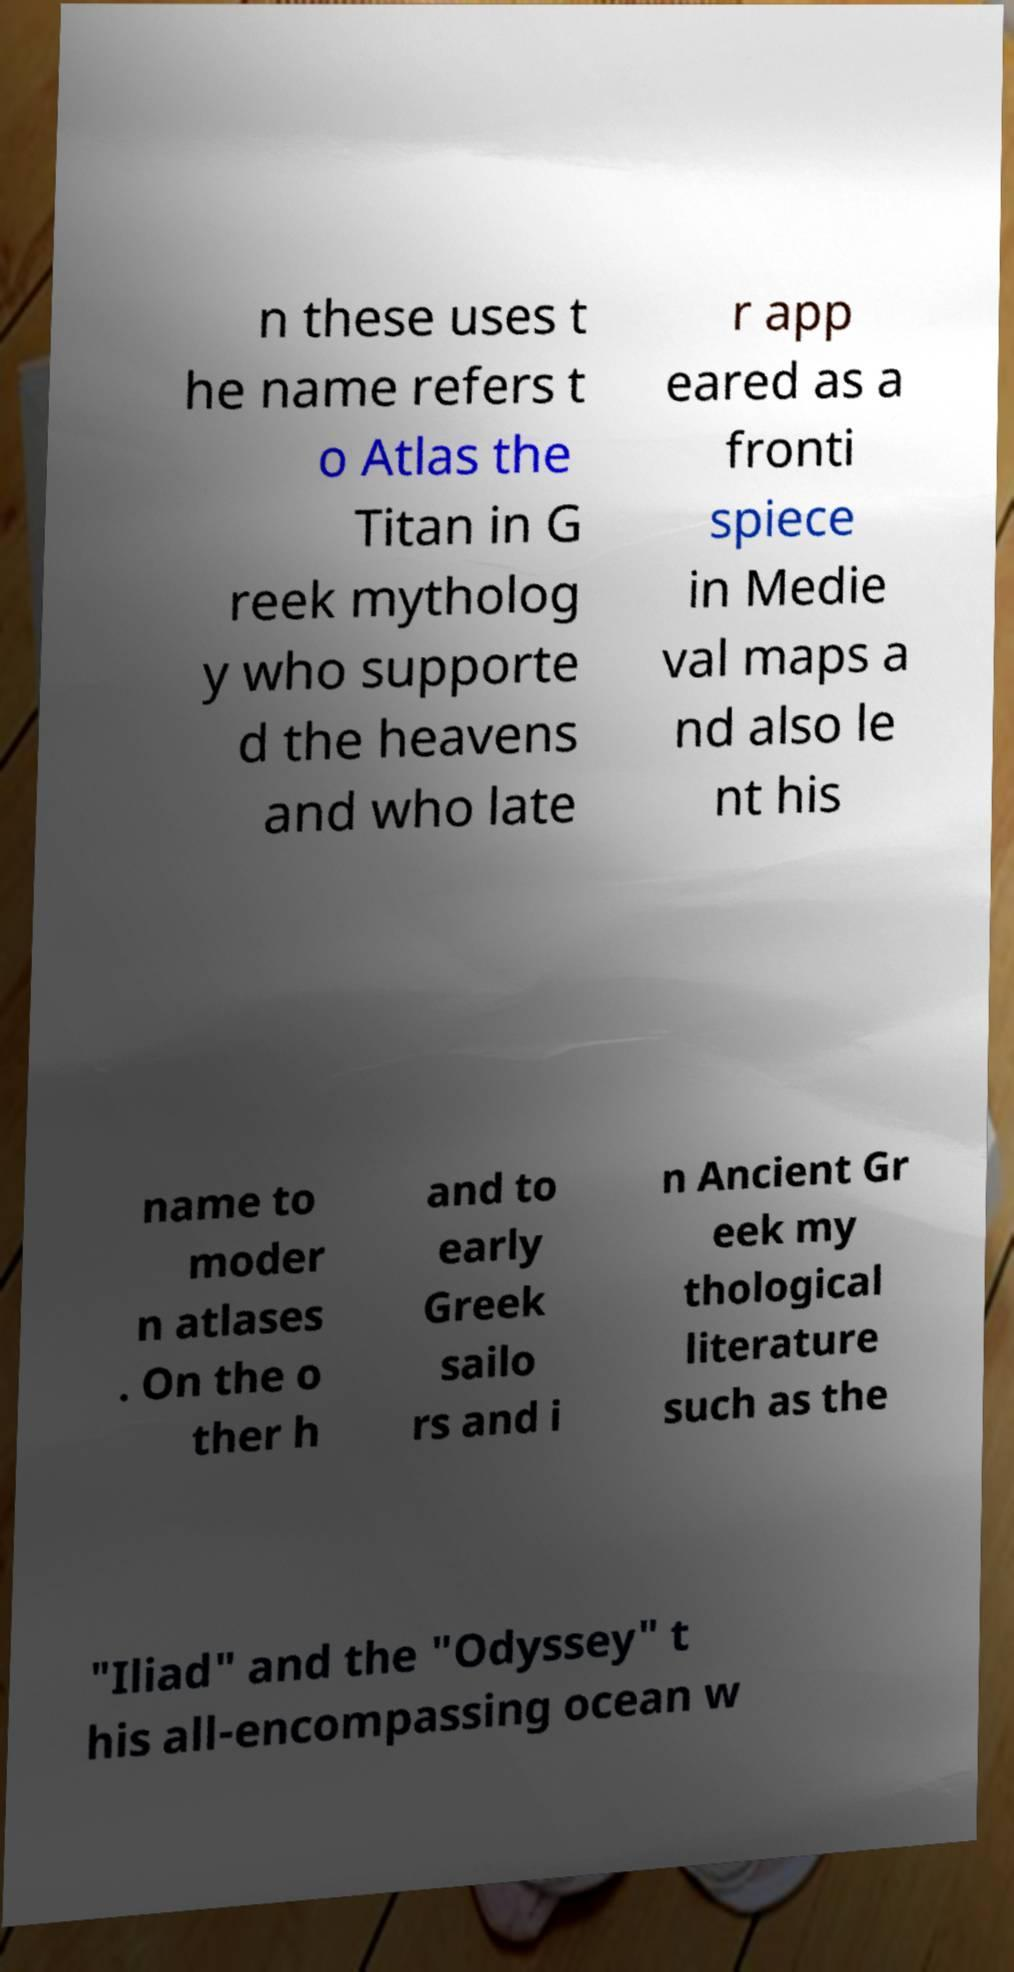Could you extract and type out the text from this image? n these uses t he name refers t o Atlas the Titan in G reek mytholog y who supporte d the heavens and who late r app eared as a fronti spiece in Medie val maps a nd also le nt his name to moder n atlases . On the o ther h and to early Greek sailo rs and i n Ancient Gr eek my thological literature such as the "Iliad" and the "Odyssey" t his all-encompassing ocean w 